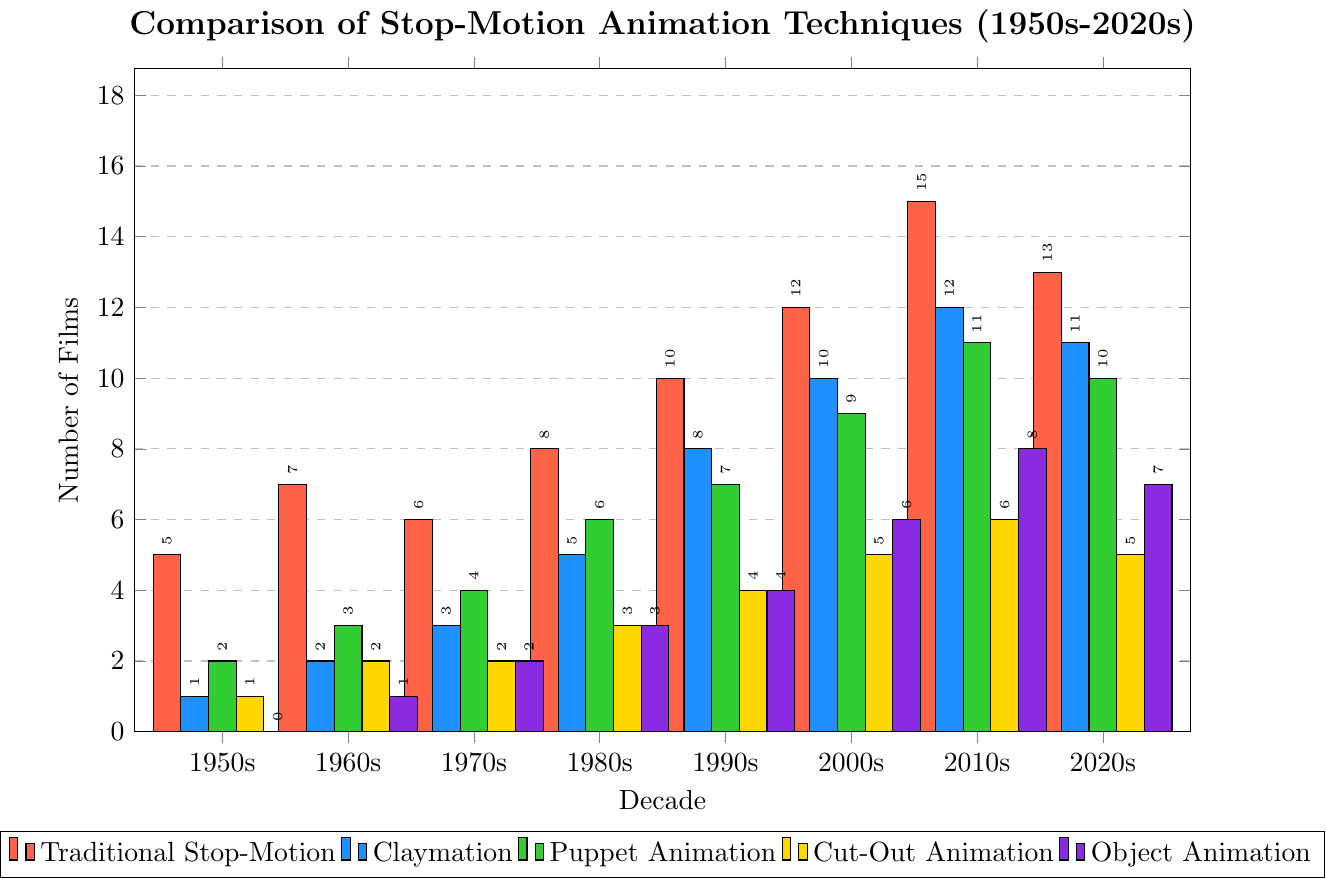Which decade had the highest number of traditional stop-motion films? Observe the bar heights for traditional stop-motion films. The tallest bar is found in the 2010s.
Answer: 2010s Which animation technique saw the greatest increase in the number of films from the 1950s to the 2020s? Calculate the difference for each technique from the 1950s to the 2020s: Traditional Stop-Motion (13-5=8), Claymation (11-1=10), Puppet Animation (10-2=8), Cut-Out Animation (5-1=4), Object Animation (7-0=7). The greatest increase is for Claymation.
Answer: Claymation How many more traditional stop-motion films were made in the 2010s compared to the 1950s? Subtract the number of traditional stop-motion films in the 1950s from the number in the 2010s (15-5=10).
Answer: 10 Which decade experienced the most balanced use of all five animation techniques? Assess the decade where the bars are closest in height for all techniques. The 1960s and 1970s show relatively balanced use across all techniques.
Answer: 1960s In which decade did object animation first appear? Check the first decade where the bar height for object animation is non-zero. The 1960s show its first appearance with 1 film.
Answer: 1960s Compare the number of puppet animation films in the 1980s and 1990s. Which decade had more? Look at the bar heights for puppet animation in the 1980s and 1990s. The 1990s had 7 films, while the 1980s had 6 films.
Answer: 1990s What is the total number of cut-out animation films made from the 1950s to the 2020s? Sum the number of cut-out animation films for each decade (1+2+2+3+4+5+6+5=28).
Answer: 28 Compare all techniques in the 2000s. Which technique had the least number of films? Observe the bar heights for each technique in the 2000s and identify the shortest bar. Cut-Out Animation had 5 films, which is the least.
Answer: Cut-Out Animation What's the trend in the number of traditional stop-motion films from the 1950s to the 2020s? Track the bar heights for traditional stop-motion films through each decade: increasing from the 1950s (5) to the 2010s (15), then slightly decreasing in the 2020s (13).
Answer: Increasing with a slight decrease after peaking in 2010s 